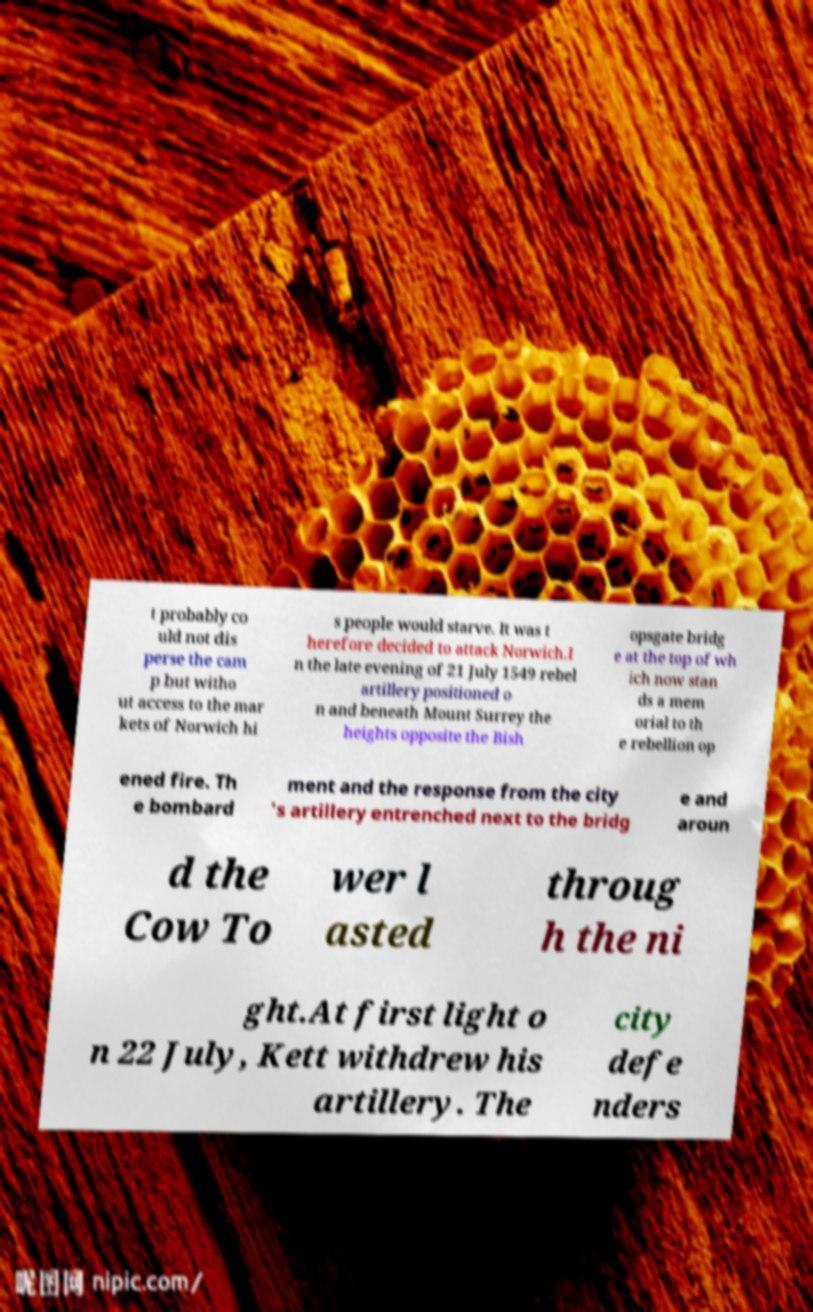Can you read and provide the text displayed in the image?This photo seems to have some interesting text. Can you extract and type it out for me? t probably co uld not dis perse the cam p but witho ut access to the mar kets of Norwich hi s people would starve. It was t herefore decided to attack Norwich.I n the late evening of 21 July 1549 rebel artillery positioned o n and beneath Mount Surrey the heights opposite the Bish opsgate bridg e at the top of wh ich now stan ds a mem orial to th e rebellion op ened fire. Th e bombard ment and the response from the city 's artillery entrenched next to the bridg e and aroun d the Cow To wer l asted throug h the ni ght.At first light o n 22 July, Kett withdrew his artillery. The city defe nders 